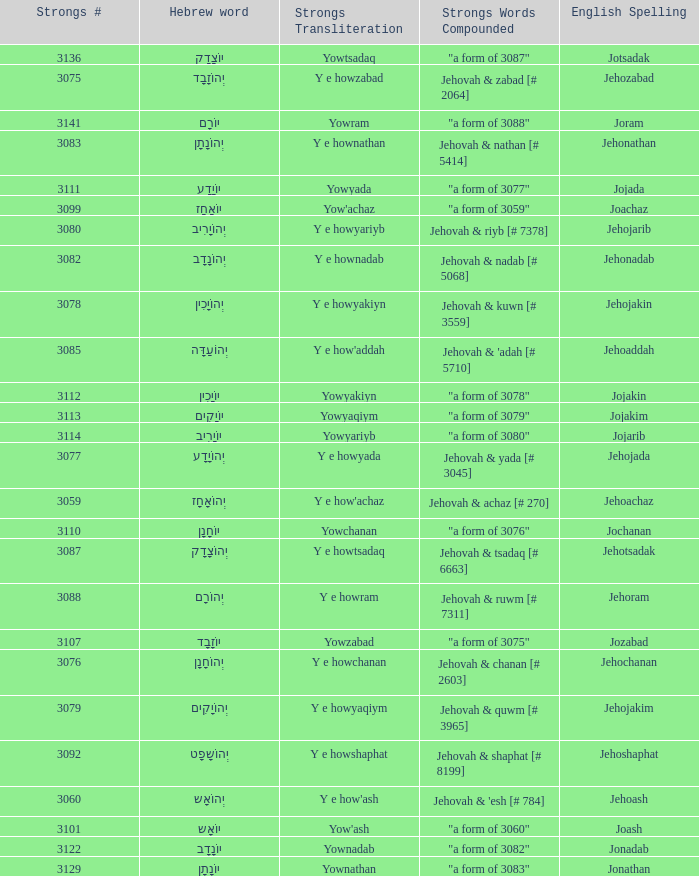How many strongs transliteration of the english spelling of the work jehojakin? 1.0. 